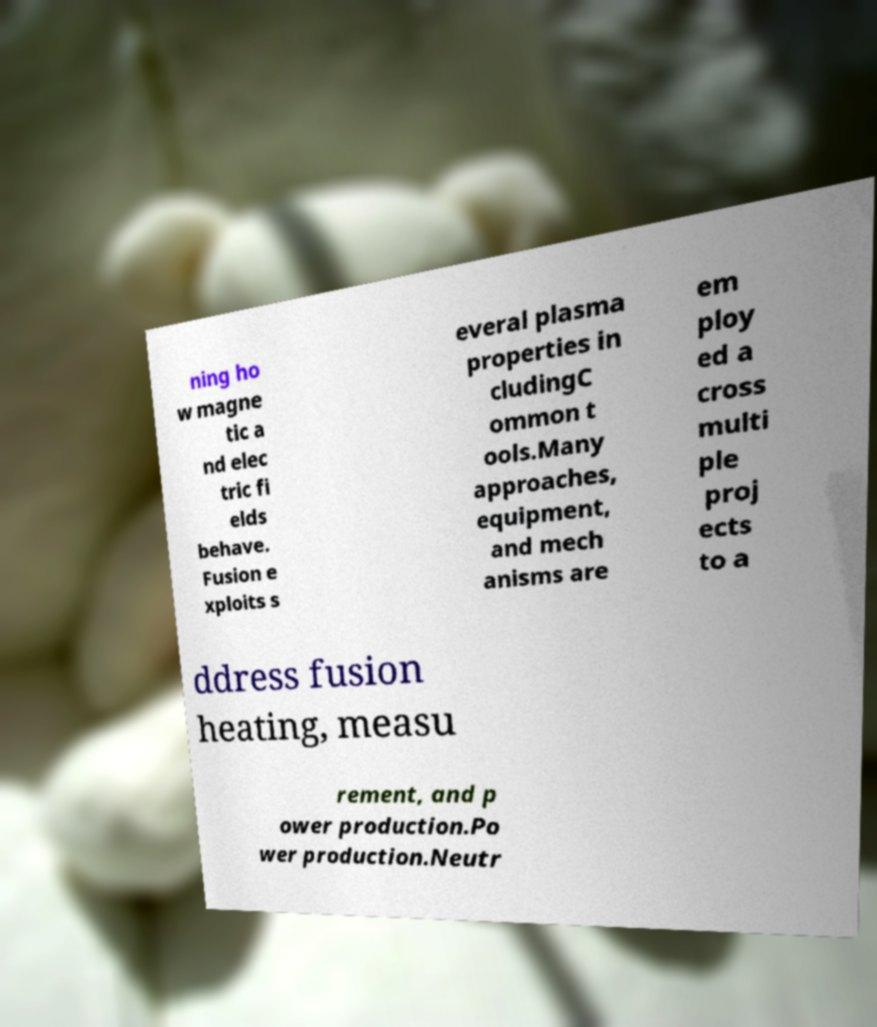I need the written content from this picture converted into text. Can you do that? ning ho w magne tic a nd elec tric fi elds behave. Fusion e xploits s everal plasma properties in cludingC ommon t ools.Many approaches, equipment, and mech anisms are em ploy ed a cross multi ple proj ects to a ddress fusion heating, measu rement, and p ower production.Po wer production.Neutr 